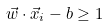Convert formula to latex. <formula><loc_0><loc_0><loc_500><loc_500>\vec { w } \cdot \vec { x } _ { i } - b \geq 1</formula> 